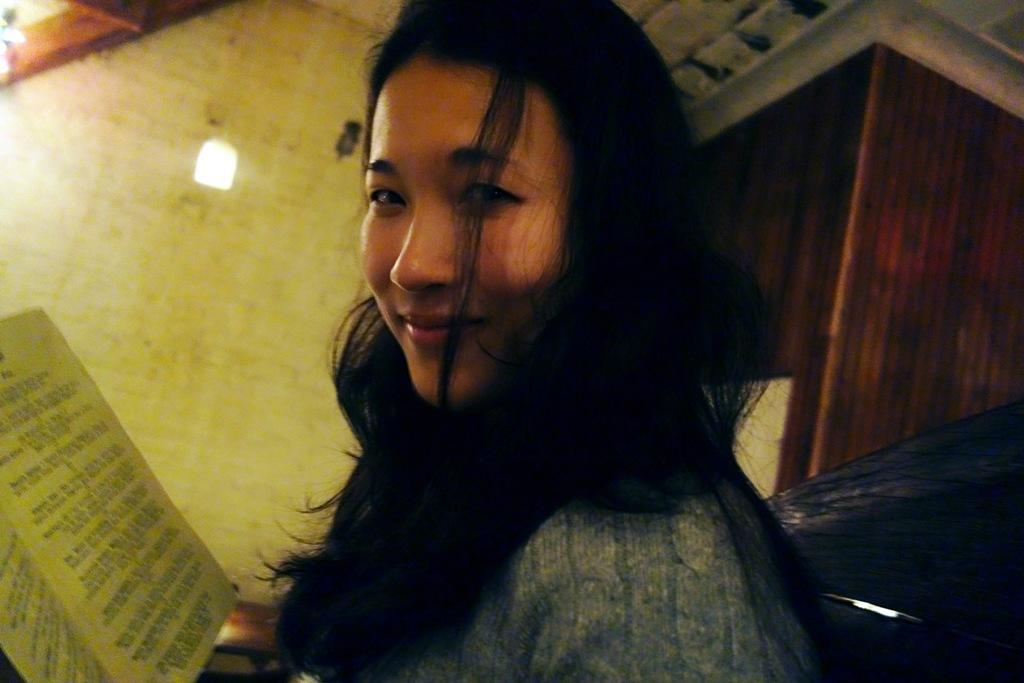Who is present in the image? There is a woman in the image. What is the woman's expression? The woman is smiling. What object can be seen in the image besides the woman? There is a book in the image. What can be seen in the background of the image? There is a wall, a light, and other objects in the background of the image. How many rings does the woman have on her fingers in the image? There is no information about rings or the woman's fingers in the image, so we cannot determine the number of rings. What type of suit is the woman wearing in the image? There is no suit present in the image; the woman is wearing a dress or other clothing. 